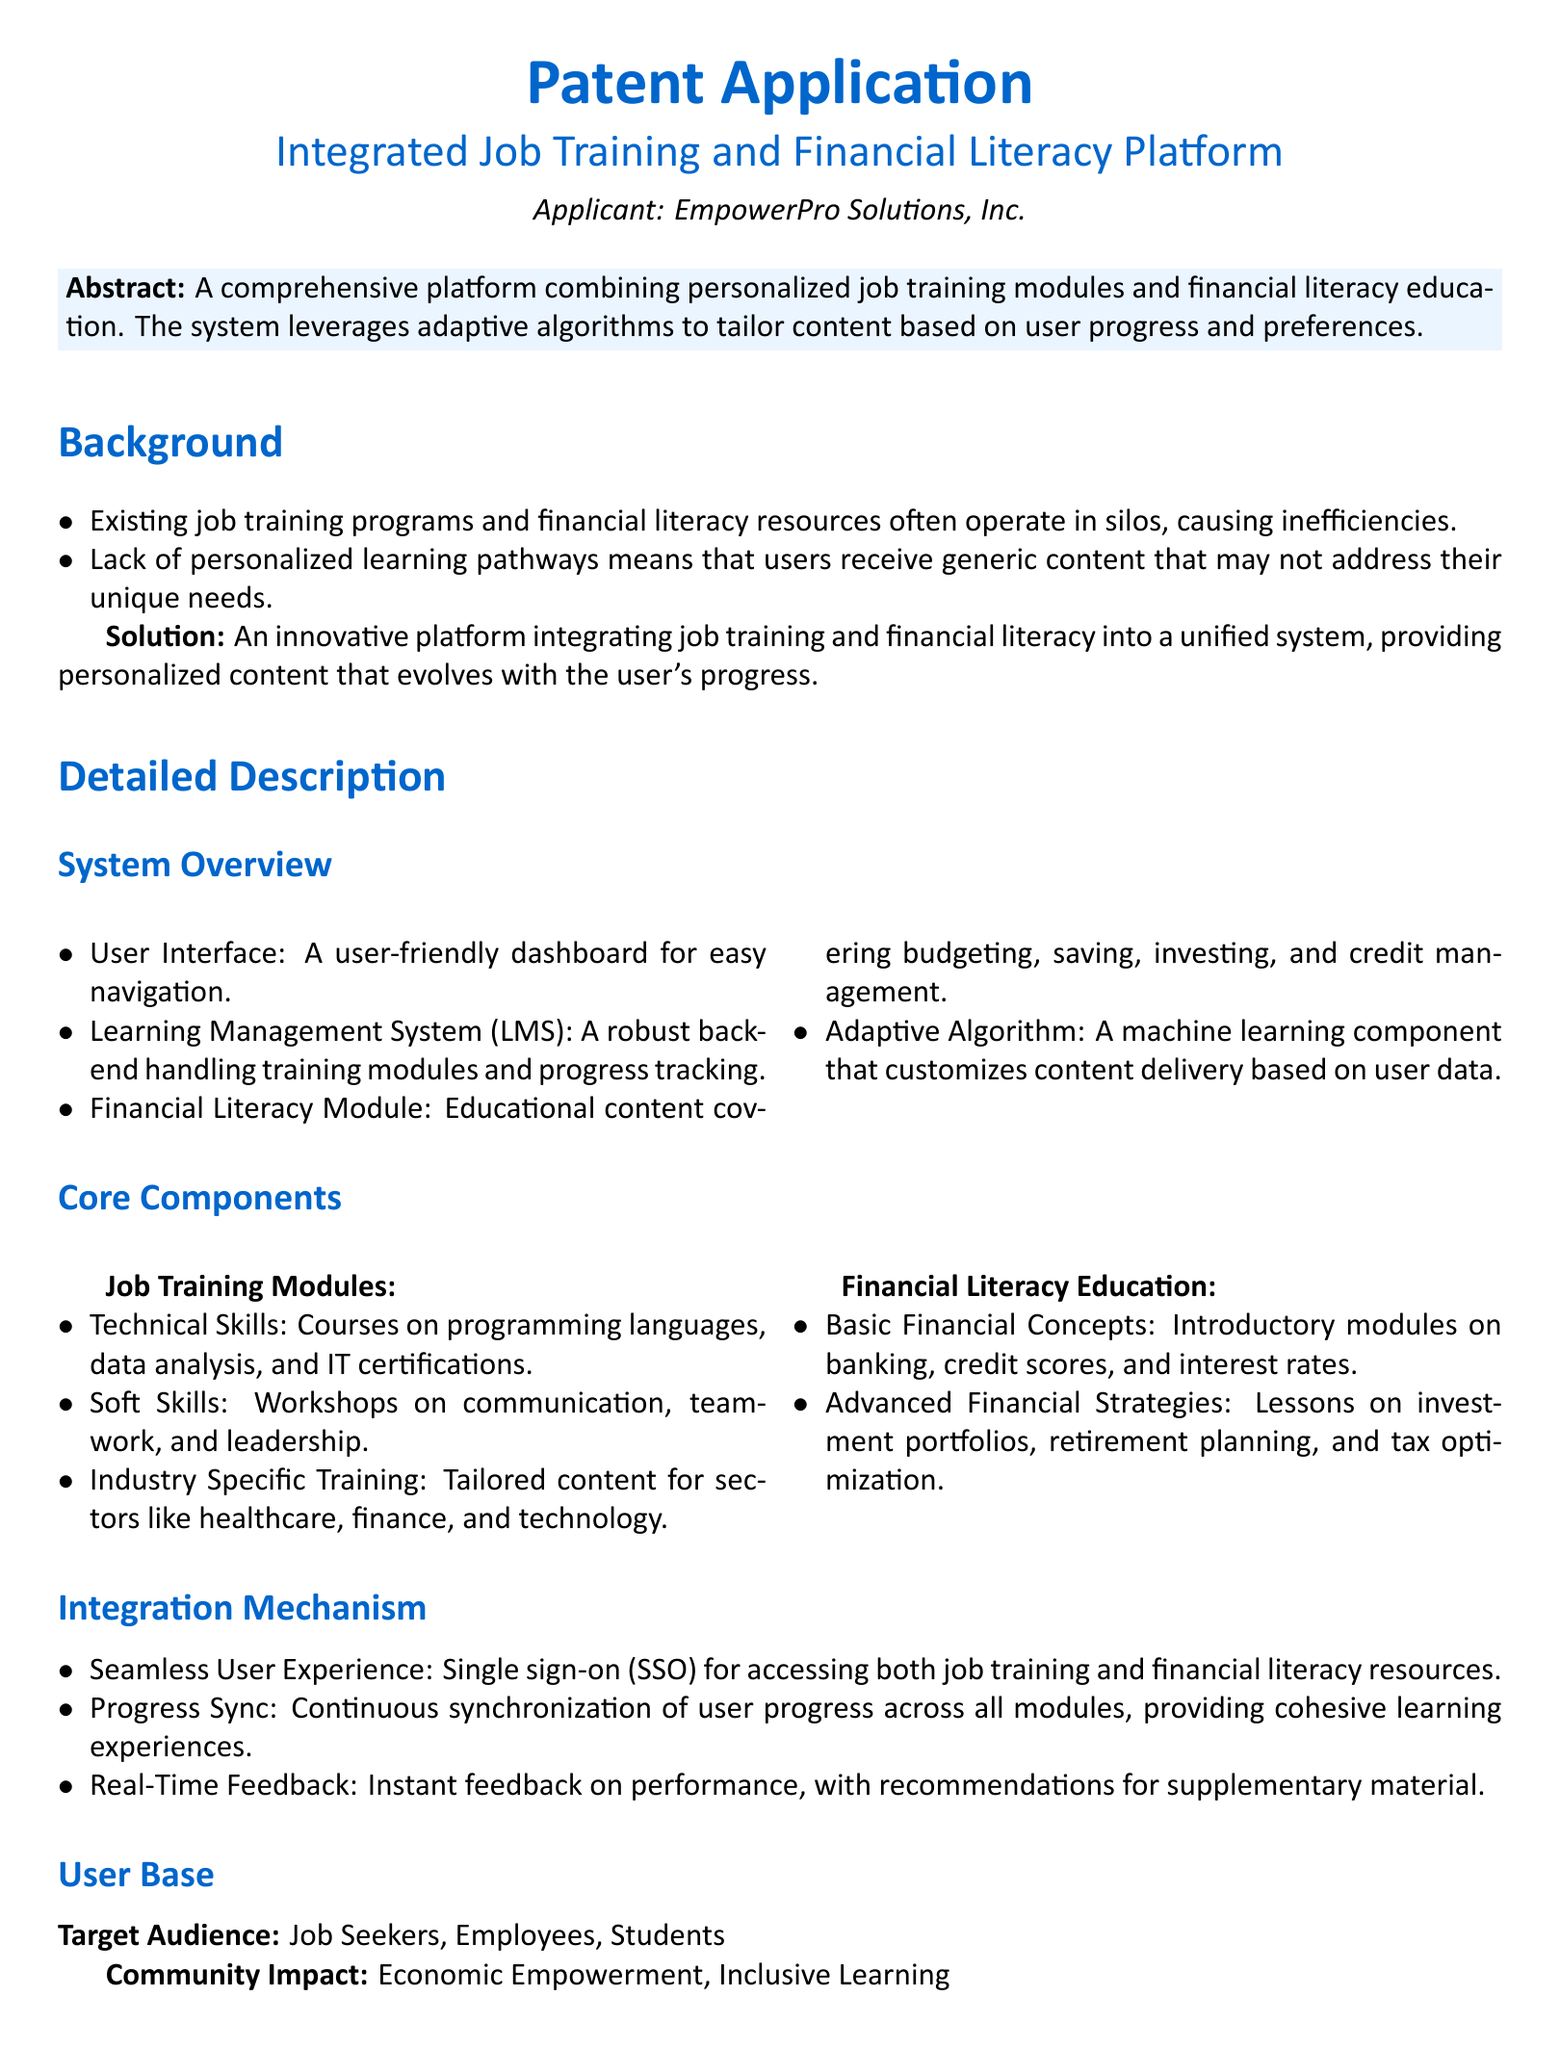What is the title of the patent application? The title is prominently displayed at the top of the document, identifying the focus of the patent application.
Answer: Integrated Job Training and Financial Literacy Platform Who is the applicant of the patent? The applicant's name appears beneath the title in the document.
Answer: EmpowerPro Solutions, Inc What type of educational content does the financial literacy module cover? The specific subjects the module addresses are listed in the detailed description section of the document.
Answer: Budgeting, saving, investing, and credit management What is the core component focused on soft skills? The document provides specific headings under core components that include various skill areas.
Answer: Workshops on communication, teamwork, and leadership What mechanism allows seamless user experience in the platform? The integration mechanism section explicitly discusses features that enhance the user experience.
Answer: Single sign-on (SSO) What are the two main types of modules offered by the platform? The detailed description outlines the core components that categorize the content offered.
Answer: Job Training Modules and Financial Literacy Education How many claims are listed in the patent application? The claims section counts the items listed that assert the uniqueness of the platform.
Answer: Three What type of users does the platform target? The user base section provides a description of the intended audience for the platform.
Answer: Job Seekers, Employees, Students 